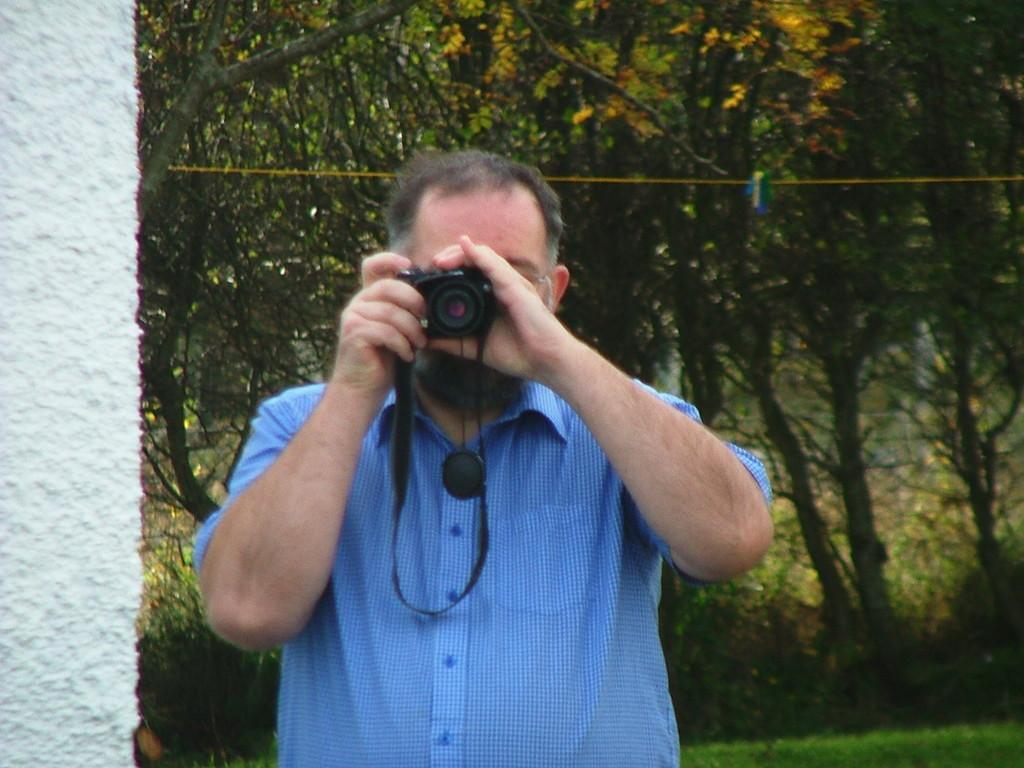What is the person in the image doing? The person is standing in the image and holding a camera. What can be seen in the background of the image? There are trees and a wall in the background of the image. How many legs does the camera have in the image? The camera does not have legs; it is an inanimate object. What type of trains can be seen passing by in the image? There are no trains present in the image. 